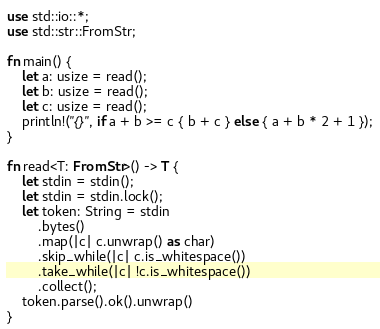Convert code to text. <code><loc_0><loc_0><loc_500><loc_500><_Rust_>use std::io::*;
use std::str::FromStr;

fn main() {
    let a: usize = read();
    let b: usize = read();
    let c: usize = read();
    println!("{}", if a + b >= c { b + c } else { a + b * 2 + 1 });
}

fn read<T: FromStr>() -> T {
    let stdin = stdin();
    let stdin = stdin.lock();
    let token: String = stdin
        .bytes()
        .map(|c| c.unwrap() as char)
        .skip_while(|c| c.is_whitespace())
        .take_while(|c| !c.is_whitespace())
        .collect();
    token.parse().ok().unwrap()
}
</code> 